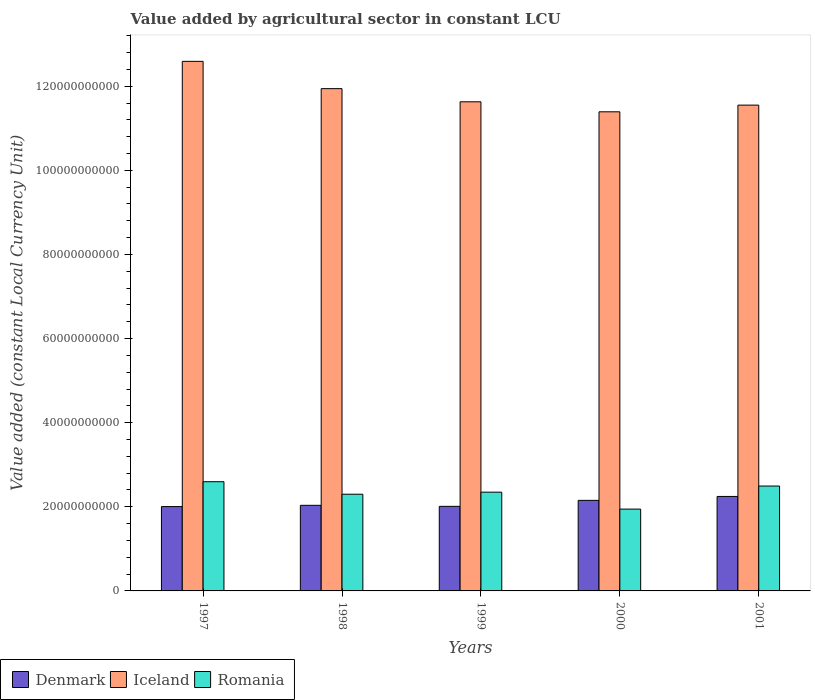Are the number of bars per tick equal to the number of legend labels?
Ensure brevity in your answer.  Yes. Are the number of bars on each tick of the X-axis equal?
Provide a short and direct response. Yes. What is the label of the 3rd group of bars from the left?
Offer a terse response. 1999. What is the value added by agricultural sector in Denmark in 1997?
Ensure brevity in your answer.  2.01e+1. Across all years, what is the maximum value added by agricultural sector in Denmark?
Keep it short and to the point. 2.25e+1. Across all years, what is the minimum value added by agricultural sector in Romania?
Ensure brevity in your answer.  1.95e+1. What is the total value added by agricultural sector in Romania in the graph?
Offer a very short reply. 1.17e+11. What is the difference between the value added by agricultural sector in Iceland in 1997 and that in 2001?
Keep it short and to the point. 1.04e+1. What is the difference between the value added by agricultural sector in Romania in 2000 and the value added by agricultural sector in Iceland in 1997?
Provide a short and direct response. -1.06e+11. What is the average value added by agricultural sector in Iceland per year?
Provide a succinct answer. 1.18e+11. In the year 2001, what is the difference between the value added by agricultural sector in Denmark and value added by agricultural sector in Iceland?
Keep it short and to the point. -9.30e+1. What is the ratio of the value added by agricultural sector in Romania in 1999 to that in 2000?
Offer a very short reply. 1.21. Is the value added by agricultural sector in Denmark in 1999 less than that in 2001?
Give a very brief answer. Yes. What is the difference between the highest and the second highest value added by agricultural sector in Iceland?
Keep it short and to the point. 6.49e+09. What is the difference between the highest and the lowest value added by agricultural sector in Denmark?
Give a very brief answer. 2.41e+09. In how many years, is the value added by agricultural sector in Iceland greater than the average value added by agricultural sector in Iceland taken over all years?
Provide a succinct answer. 2. Is the sum of the value added by agricultural sector in Denmark in 1997 and 2001 greater than the maximum value added by agricultural sector in Romania across all years?
Your answer should be very brief. Yes. What does the 2nd bar from the left in 2000 represents?
Your answer should be compact. Iceland. What does the 1st bar from the right in 2001 represents?
Give a very brief answer. Romania. How many bars are there?
Give a very brief answer. 15. Are all the bars in the graph horizontal?
Your answer should be very brief. No. Are the values on the major ticks of Y-axis written in scientific E-notation?
Offer a very short reply. No. Does the graph contain any zero values?
Your answer should be compact. No. Does the graph contain grids?
Your response must be concise. No. Where does the legend appear in the graph?
Ensure brevity in your answer.  Bottom left. How are the legend labels stacked?
Provide a succinct answer. Horizontal. What is the title of the graph?
Offer a terse response. Value added by agricultural sector in constant LCU. Does "Denmark" appear as one of the legend labels in the graph?
Make the answer very short. Yes. What is the label or title of the Y-axis?
Provide a short and direct response. Value added (constant Local Currency Unit). What is the Value added (constant Local Currency Unit) of Denmark in 1997?
Your response must be concise. 2.01e+1. What is the Value added (constant Local Currency Unit) in Iceland in 1997?
Provide a succinct answer. 1.26e+11. What is the Value added (constant Local Currency Unit) of Romania in 1997?
Make the answer very short. 2.60e+1. What is the Value added (constant Local Currency Unit) in Denmark in 1998?
Ensure brevity in your answer.  2.04e+1. What is the Value added (constant Local Currency Unit) in Iceland in 1998?
Keep it short and to the point. 1.19e+11. What is the Value added (constant Local Currency Unit) in Romania in 1998?
Keep it short and to the point. 2.30e+1. What is the Value added (constant Local Currency Unit) in Denmark in 1999?
Keep it short and to the point. 2.01e+1. What is the Value added (constant Local Currency Unit) in Iceland in 1999?
Provide a succinct answer. 1.16e+11. What is the Value added (constant Local Currency Unit) in Romania in 1999?
Provide a succinct answer. 2.35e+1. What is the Value added (constant Local Currency Unit) in Denmark in 2000?
Keep it short and to the point. 2.15e+1. What is the Value added (constant Local Currency Unit) of Iceland in 2000?
Keep it short and to the point. 1.14e+11. What is the Value added (constant Local Currency Unit) in Romania in 2000?
Give a very brief answer. 1.95e+1. What is the Value added (constant Local Currency Unit) of Denmark in 2001?
Your answer should be compact. 2.25e+1. What is the Value added (constant Local Currency Unit) in Iceland in 2001?
Make the answer very short. 1.16e+11. What is the Value added (constant Local Currency Unit) of Romania in 2001?
Provide a succinct answer. 2.49e+1. Across all years, what is the maximum Value added (constant Local Currency Unit) in Denmark?
Offer a terse response. 2.25e+1. Across all years, what is the maximum Value added (constant Local Currency Unit) of Iceland?
Keep it short and to the point. 1.26e+11. Across all years, what is the maximum Value added (constant Local Currency Unit) of Romania?
Keep it short and to the point. 2.60e+1. Across all years, what is the minimum Value added (constant Local Currency Unit) of Denmark?
Make the answer very short. 2.01e+1. Across all years, what is the minimum Value added (constant Local Currency Unit) of Iceland?
Your response must be concise. 1.14e+11. Across all years, what is the minimum Value added (constant Local Currency Unit) in Romania?
Offer a very short reply. 1.95e+1. What is the total Value added (constant Local Currency Unit) of Denmark in the graph?
Keep it short and to the point. 1.05e+11. What is the total Value added (constant Local Currency Unit) of Iceland in the graph?
Ensure brevity in your answer.  5.91e+11. What is the total Value added (constant Local Currency Unit) in Romania in the graph?
Provide a succinct answer. 1.17e+11. What is the difference between the Value added (constant Local Currency Unit) in Denmark in 1997 and that in 1998?
Keep it short and to the point. -3.03e+08. What is the difference between the Value added (constant Local Currency Unit) in Iceland in 1997 and that in 1998?
Make the answer very short. 6.49e+09. What is the difference between the Value added (constant Local Currency Unit) in Romania in 1997 and that in 1998?
Make the answer very short. 2.98e+09. What is the difference between the Value added (constant Local Currency Unit) of Denmark in 1997 and that in 1999?
Offer a very short reply. -5.50e+07. What is the difference between the Value added (constant Local Currency Unit) in Iceland in 1997 and that in 1999?
Ensure brevity in your answer.  9.62e+09. What is the difference between the Value added (constant Local Currency Unit) of Romania in 1997 and that in 1999?
Provide a short and direct response. 2.49e+09. What is the difference between the Value added (constant Local Currency Unit) of Denmark in 1997 and that in 2000?
Ensure brevity in your answer.  -1.48e+09. What is the difference between the Value added (constant Local Currency Unit) of Iceland in 1997 and that in 2000?
Your answer should be very brief. 1.20e+1. What is the difference between the Value added (constant Local Currency Unit) of Romania in 1997 and that in 2000?
Provide a short and direct response. 6.51e+09. What is the difference between the Value added (constant Local Currency Unit) in Denmark in 1997 and that in 2001?
Provide a succinct answer. -2.41e+09. What is the difference between the Value added (constant Local Currency Unit) of Iceland in 1997 and that in 2001?
Provide a short and direct response. 1.04e+1. What is the difference between the Value added (constant Local Currency Unit) in Romania in 1997 and that in 2001?
Give a very brief answer. 1.03e+09. What is the difference between the Value added (constant Local Currency Unit) in Denmark in 1998 and that in 1999?
Keep it short and to the point. 2.48e+08. What is the difference between the Value added (constant Local Currency Unit) in Iceland in 1998 and that in 1999?
Offer a terse response. 3.13e+09. What is the difference between the Value added (constant Local Currency Unit) of Romania in 1998 and that in 1999?
Your answer should be compact. -4.91e+08. What is the difference between the Value added (constant Local Currency Unit) of Denmark in 1998 and that in 2000?
Make the answer very short. -1.18e+09. What is the difference between the Value added (constant Local Currency Unit) of Iceland in 1998 and that in 2000?
Provide a succinct answer. 5.51e+09. What is the difference between the Value added (constant Local Currency Unit) of Romania in 1998 and that in 2000?
Make the answer very short. 3.53e+09. What is the difference between the Value added (constant Local Currency Unit) of Denmark in 1998 and that in 2001?
Provide a succinct answer. -2.11e+09. What is the difference between the Value added (constant Local Currency Unit) of Iceland in 1998 and that in 2001?
Make the answer very short. 3.92e+09. What is the difference between the Value added (constant Local Currency Unit) of Romania in 1998 and that in 2001?
Offer a terse response. -1.95e+09. What is the difference between the Value added (constant Local Currency Unit) in Denmark in 1999 and that in 2000?
Offer a terse response. -1.42e+09. What is the difference between the Value added (constant Local Currency Unit) of Iceland in 1999 and that in 2000?
Ensure brevity in your answer.  2.38e+09. What is the difference between the Value added (constant Local Currency Unit) in Romania in 1999 and that in 2000?
Ensure brevity in your answer.  4.03e+09. What is the difference between the Value added (constant Local Currency Unit) of Denmark in 1999 and that in 2001?
Keep it short and to the point. -2.36e+09. What is the difference between the Value added (constant Local Currency Unit) of Iceland in 1999 and that in 2001?
Keep it short and to the point. 7.86e+08. What is the difference between the Value added (constant Local Currency Unit) in Romania in 1999 and that in 2001?
Provide a succinct answer. -1.46e+09. What is the difference between the Value added (constant Local Currency Unit) of Denmark in 2000 and that in 2001?
Provide a succinct answer. -9.33e+08. What is the difference between the Value added (constant Local Currency Unit) in Iceland in 2000 and that in 2001?
Your answer should be very brief. -1.59e+09. What is the difference between the Value added (constant Local Currency Unit) of Romania in 2000 and that in 2001?
Your answer should be compact. -5.48e+09. What is the difference between the Value added (constant Local Currency Unit) in Denmark in 1997 and the Value added (constant Local Currency Unit) in Iceland in 1998?
Offer a terse response. -9.94e+1. What is the difference between the Value added (constant Local Currency Unit) in Denmark in 1997 and the Value added (constant Local Currency Unit) in Romania in 1998?
Your answer should be very brief. -2.94e+09. What is the difference between the Value added (constant Local Currency Unit) in Iceland in 1997 and the Value added (constant Local Currency Unit) in Romania in 1998?
Your response must be concise. 1.03e+11. What is the difference between the Value added (constant Local Currency Unit) in Denmark in 1997 and the Value added (constant Local Currency Unit) in Iceland in 1999?
Offer a very short reply. -9.62e+1. What is the difference between the Value added (constant Local Currency Unit) in Denmark in 1997 and the Value added (constant Local Currency Unit) in Romania in 1999?
Offer a terse response. -3.43e+09. What is the difference between the Value added (constant Local Currency Unit) of Iceland in 1997 and the Value added (constant Local Currency Unit) of Romania in 1999?
Provide a short and direct response. 1.02e+11. What is the difference between the Value added (constant Local Currency Unit) in Denmark in 1997 and the Value added (constant Local Currency Unit) in Iceland in 2000?
Keep it short and to the point. -9.39e+1. What is the difference between the Value added (constant Local Currency Unit) of Denmark in 1997 and the Value added (constant Local Currency Unit) of Romania in 2000?
Ensure brevity in your answer.  5.97e+08. What is the difference between the Value added (constant Local Currency Unit) in Iceland in 1997 and the Value added (constant Local Currency Unit) in Romania in 2000?
Your answer should be very brief. 1.06e+11. What is the difference between the Value added (constant Local Currency Unit) in Denmark in 1997 and the Value added (constant Local Currency Unit) in Iceland in 2001?
Ensure brevity in your answer.  -9.55e+1. What is the difference between the Value added (constant Local Currency Unit) of Denmark in 1997 and the Value added (constant Local Currency Unit) of Romania in 2001?
Keep it short and to the point. -4.89e+09. What is the difference between the Value added (constant Local Currency Unit) of Iceland in 1997 and the Value added (constant Local Currency Unit) of Romania in 2001?
Your answer should be compact. 1.01e+11. What is the difference between the Value added (constant Local Currency Unit) of Denmark in 1998 and the Value added (constant Local Currency Unit) of Iceland in 1999?
Your response must be concise. -9.59e+1. What is the difference between the Value added (constant Local Currency Unit) in Denmark in 1998 and the Value added (constant Local Currency Unit) in Romania in 1999?
Your answer should be compact. -3.13e+09. What is the difference between the Value added (constant Local Currency Unit) of Iceland in 1998 and the Value added (constant Local Currency Unit) of Romania in 1999?
Your answer should be compact. 9.59e+1. What is the difference between the Value added (constant Local Currency Unit) of Denmark in 1998 and the Value added (constant Local Currency Unit) of Iceland in 2000?
Keep it short and to the point. -9.36e+1. What is the difference between the Value added (constant Local Currency Unit) in Denmark in 1998 and the Value added (constant Local Currency Unit) in Romania in 2000?
Give a very brief answer. 9.00e+08. What is the difference between the Value added (constant Local Currency Unit) in Iceland in 1998 and the Value added (constant Local Currency Unit) in Romania in 2000?
Provide a succinct answer. 1.00e+11. What is the difference between the Value added (constant Local Currency Unit) in Denmark in 1998 and the Value added (constant Local Currency Unit) in Iceland in 2001?
Provide a short and direct response. -9.52e+1. What is the difference between the Value added (constant Local Currency Unit) in Denmark in 1998 and the Value added (constant Local Currency Unit) in Romania in 2001?
Your response must be concise. -4.58e+09. What is the difference between the Value added (constant Local Currency Unit) in Iceland in 1998 and the Value added (constant Local Currency Unit) in Romania in 2001?
Ensure brevity in your answer.  9.45e+1. What is the difference between the Value added (constant Local Currency Unit) of Denmark in 1999 and the Value added (constant Local Currency Unit) of Iceland in 2000?
Offer a terse response. -9.38e+1. What is the difference between the Value added (constant Local Currency Unit) in Denmark in 1999 and the Value added (constant Local Currency Unit) in Romania in 2000?
Ensure brevity in your answer.  6.52e+08. What is the difference between the Value added (constant Local Currency Unit) of Iceland in 1999 and the Value added (constant Local Currency Unit) of Romania in 2000?
Provide a succinct answer. 9.68e+1. What is the difference between the Value added (constant Local Currency Unit) in Denmark in 1999 and the Value added (constant Local Currency Unit) in Iceland in 2001?
Your answer should be very brief. -9.54e+1. What is the difference between the Value added (constant Local Currency Unit) in Denmark in 1999 and the Value added (constant Local Currency Unit) in Romania in 2001?
Give a very brief answer. -4.83e+09. What is the difference between the Value added (constant Local Currency Unit) of Iceland in 1999 and the Value added (constant Local Currency Unit) of Romania in 2001?
Ensure brevity in your answer.  9.14e+1. What is the difference between the Value added (constant Local Currency Unit) of Denmark in 2000 and the Value added (constant Local Currency Unit) of Iceland in 2001?
Make the answer very short. -9.40e+1. What is the difference between the Value added (constant Local Currency Unit) of Denmark in 2000 and the Value added (constant Local Currency Unit) of Romania in 2001?
Make the answer very short. -3.41e+09. What is the difference between the Value added (constant Local Currency Unit) of Iceland in 2000 and the Value added (constant Local Currency Unit) of Romania in 2001?
Provide a succinct answer. 8.90e+1. What is the average Value added (constant Local Currency Unit) of Denmark per year?
Your response must be concise. 2.09e+1. What is the average Value added (constant Local Currency Unit) of Iceland per year?
Provide a short and direct response. 1.18e+11. What is the average Value added (constant Local Currency Unit) of Romania per year?
Offer a terse response. 2.34e+1. In the year 1997, what is the difference between the Value added (constant Local Currency Unit) in Denmark and Value added (constant Local Currency Unit) in Iceland?
Ensure brevity in your answer.  -1.06e+11. In the year 1997, what is the difference between the Value added (constant Local Currency Unit) of Denmark and Value added (constant Local Currency Unit) of Romania?
Give a very brief answer. -5.92e+09. In the year 1997, what is the difference between the Value added (constant Local Currency Unit) of Iceland and Value added (constant Local Currency Unit) of Romania?
Your answer should be compact. 9.99e+1. In the year 1998, what is the difference between the Value added (constant Local Currency Unit) in Denmark and Value added (constant Local Currency Unit) in Iceland?
Your answer should be very brief. -9.91e+1. In the year 1998, what is the difference between the Value added (constant Local Currency Unit) in Denmark and Value added (constant Local Currency Unit) in Romania?
Your answer should be compact. -2.64e+09. In the year 1998, what is the difference between the Value added (constant Local Currency Unit) in Iceland and Value added (constant Local Currency Unit) in Romania?
Provide a short and direct response. 9.64e+1. In the year 1999, what is the difference between the Value added (constant Local Currency Unit) in Denmark and Value added (constant Local Currency Unit) in Iceland?
Keep it short and to the point. -9.62e+1. In the year 1999, what is the difference between the Value added (constant Local Currency Unit) of Denmark and Value added (constant Local Currency Unit) of Romania?
Offer a terse response. -3.37e+09. In the year 1999, what is the difference between the Value added (constant Local Currency Unit) in Iceland and Value added (constant Local Currency Unit) in Romania?
Keep it short and to the point. 9.28e+1. In the year 2000, what is the difference between the Value added (constant Local Currency Unit) in Denmark and Value added (constant Local Currency Unit) in Iceland?
Offer a very short reply. -9.24e+1. In the year 2000, what is the difference between the Value added (constant Local Currency Unit) in Denmark and Value added (constant Local Currency Unit) in Romania?
Make the answer very short. 2.08e+09. In the year 2000, what is the difference between the Value added (constant Local Currency Unit) in Iceland and Value added (constant Local Currency Unit) in Romania?
Provide a succinct answer. 9.45e+1. In the year 2001, what is the difference between the Value added (constant Local Currency Unit) in Denmark and Value added (constant Local Currency Unit) in Iceland?
Offer a very short reply. -9.30e+1. In the year 2001, what is the difference between the Value added (constant Local Currency Unit) in Denmark and Value added (constant Local Currency Unit) in Romania?
Provide a short and direct response. -2.47e+09. In the year 2001, what is the difference between the Value added (constant Local Currency Unit) in Iceland and Value added (constant Local Currency Unit) in Romania?
Provide a succinct answer. 9.06e+1. What is the ratio of the Value added (constant Local Currency Unit) of Denmark in 1997 to that in 1998?
Your answer should be compact. 0.99. What is the ratio of the Value added (constant Local Currency Unit) of Iceland in 1997 to that in 1998?
Provide a short and direct response. 1.05. What is the ratio of the Value added (constant Local Currency Unit) of Romania in 1997 to that in 1998?
Your response must be concise. 1.13. What is the ratio of the Value added (constant Local Currency Unit) in Denmark in 1997 to that in 1999?
Your response must be concise. 1. What is the ratio of the Value added (constant Local Currency Unit) of Iceland in 1997 to that in 1999?
Your response must be concise. 1.08. What is the ratio of the Value added (constant Local Currency Unit) in Romania in 1997 to that in 1999?
Your response must be concise. 1.11. What is the ratio of the Value added (constant Local Currency Unit) in Denmark in 1997 to that in 2000?
Ensure brevity in your answer.  0.93. What is the ratio of the Value added (constant Local Currency Unit) of Iceland in 1997 to that in 2000?
Ensure brevity in your answer.  1.11. What is the ratio of the Value added (constant Local Currency Unit) of Romania in 1997 to that in 2000?
Provide a succinct answer. 1.33. What is the ratio of the Value added (constant Local Currency Unit) in Denmark in 1997 to that in 2001?
Give a very brief answer. 0.89. What is the ratio of the Value added (constant Local Currency Unit) of Iceland in 1997 to that in 2001?
Ensure brevity in your answer.  1.09. What is the ratio of the Value added (constant Local Currency Unit) of Romania in 1997 to that in 2001?
Keep it short and to the point. 1.04. What is the ratio of the Value added (constant Local Currency Unit) in Denmark in 1998 to that in 1999?
Keep it short and to the point. 1.01. What is the ratio of the Value added (constant Local Currency Unit) of Iceland in 1998 to that in 1999?
Offer a very short reply. 1.03. What is the ratio of the Value added (constant Local Currency Unit) of Romania in 1998 to that in 1999?
Ensure brevity in your answer.  0.98. What is the ratio of the Value added (constant Local Currency Unit) of Denmark in 1998 to that in 2000?
Your answer should be compact. 0.95. What is the ratio of the Value added (constant Local Currency Unit) of Iceland in 1998 to that in 2000?
Ensure brevity in your answer.  1.05. What is the ratio of the Value added (constant Local Currency Unit) of Romania in 1998 to that in 2000?
Your response must be concise. 1.18. What is the ratio of the Value added (constant Local Currency Unit) in Denmark in 1998 to that in 2001?
Provide a short and direct response. 0.91. What is the ratio of the Value added (constant Local Currency Unit) in Iceland in 1998 to that in 2001?
Ensure brevity in your answer.  1.03. What is the ratio of the Value added (constant Local Currency Unit) of Romania in 1998 to that in 2001?
Provide a succinct answer. 0.92. What is the ratio of the Value added (constant Local Currency Unit) of Denmark in 1999 to that in 2000?
Your answer should be compact. 0.93. What is the ratio of the Value added (constant Local Currency Unit) in Iceland in 1999 to that in 2000?
Give a very brief answer. 1.02. What is the ratio of the Value added (constant Local Currency Unit) in Romania in 1999 to that in 2000?
Make the answer very short. 1.21. What is the ratio of the Value added (constant Local Currency Unit) in Denmark in 1999 to that in 2001?
Ensure brevity in your answer.  0.9. What is the ratio of the Value added (constant Local Currency Unit) in Iceland in 1999 to that in 2001?
Offer a terse response. 1.01. What is the ratio of the Value added (constant Local Currency Unit) in Romania in 1999 to that in 2001?
Your answer should be very brief. 0.94. What is the ratio of the Value added (constant Local Currency Unit) of Denmark in 2000 to that in 2001?
Keep it short and to the point. 0.96. What is the ratio of the Value added (constant Local Currency Unit) in Iceland in 2000 to that in 2001?
Offer a very short reply. 0.99. What is the ratio of the Value added (constant Local Currency Unit) in Romania in 2000 to that in 2001?
Make the answer very short. 0.78. What is the difference between the highest and the second highest Value added (constant Local Currency Unit) in Denmark?
Make the answer very short. 9.33e+08. What is the difference between the highest and the second highest Value added (constant Local Currency Unit) of Iceland?
Your answer should be very brief. 6.49e+09. What is the difference between the highest and the second highest Value added (constant Local Currency Unit) in Romania?
Your response must be concise. 1.03e+09. What is the difference between the highest and the lowest Value added (constant Local Currency Unit) of Denmark?
Your response must be concise. 2.41e+09. What is the difference between the highest and the lowest Value added (constant Local Currency Unit) in Iceland?
Provide a succinct answer. 1.20e+1. What is the difference between the highest and the lowest Value added (constant Local Currency Unit) of Romania?
Offer a terse response. 6.51e+09. 